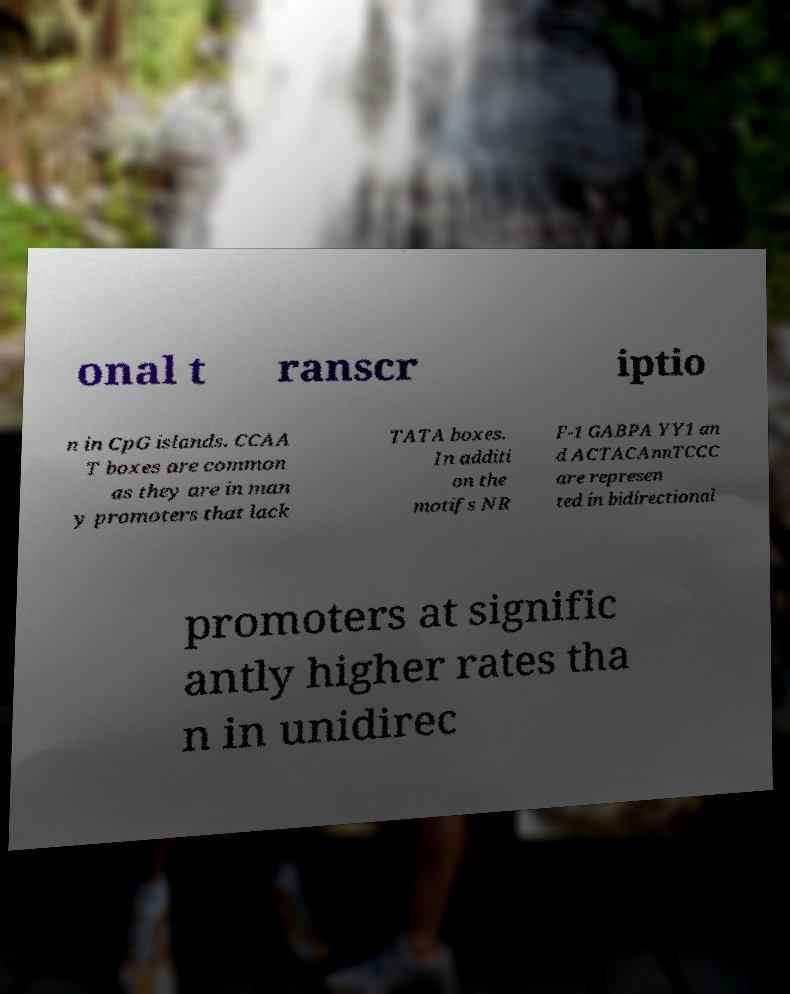Could you assist in decoding the text presented in this image and type it out clearly? onal t ranscr iptio n in CpG islands. CCAA T boxes are common as they are in man y promoters that lack TATA boxes. In additi on the motifs NR F-1 GABPA YY1 an d ACTACAnnTCCC are represen ted in bidirectional promoters at signific antly higher rates tha n in unidirec 